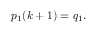Convert formula to latex. <formula><loc_0><loc_0><loc_500><loc_500>p _ { 1 } ( k + 1 ) = q _ { 1 } .</formula> 